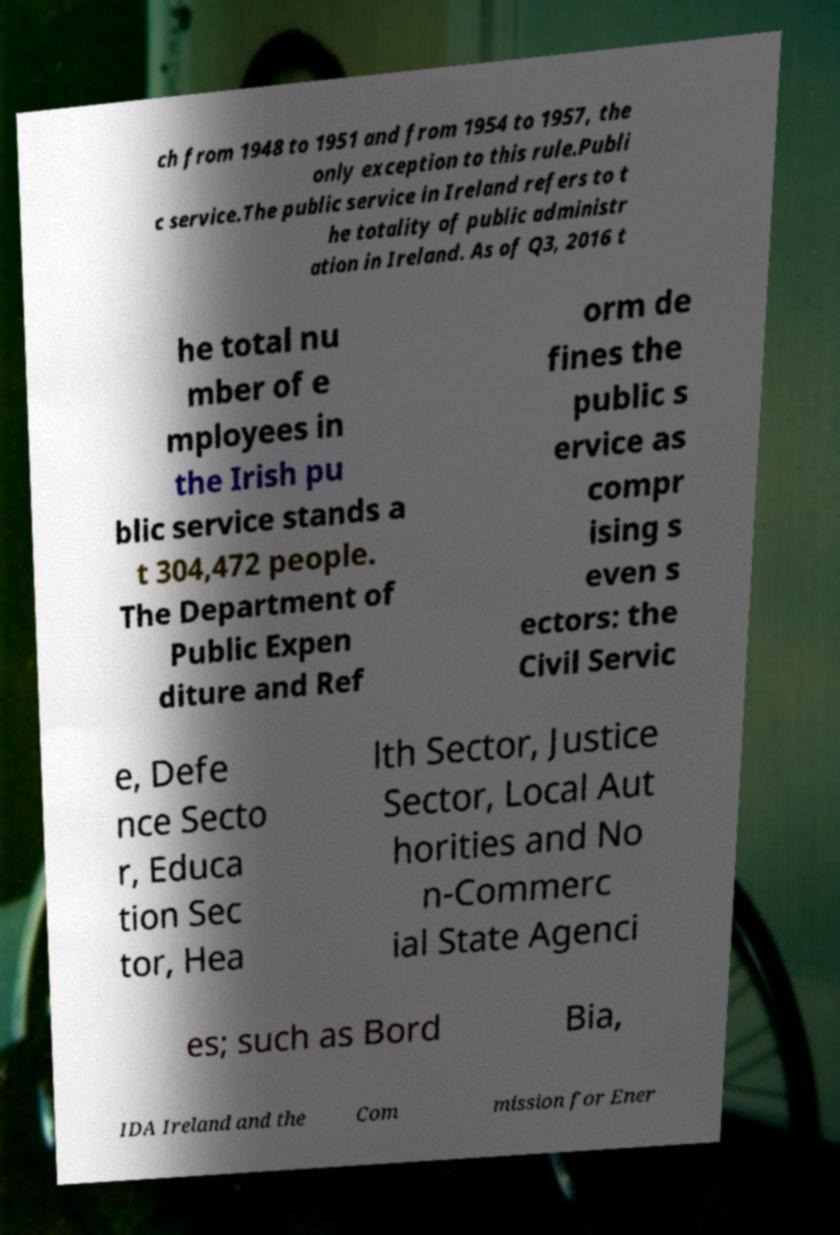I need the written content from this picture converted into text. Can you do that? ch from 1948 to 1951 and from 1954 to 1957, the only exception to this rule.Publi c service.The public service in Ireland refers to t he totality of public administr ation in Ireland. As of Q3, 2016 t he total nu mber of e mployees in the Irish pu blic service stands a t 304,472 people. The Department of Public Expen diture and Ref orm de fines the public s ervice as compr ising s even s ectors: the Civil Servic e, Defe nce Secto r, Educa tion Sec tor, Hea lth Sector, Justice Sector, Local Aut horities and No n-Commerc ial State Agenci es; such as Bord Bia, IDA Ireland and the Com mission for Ener 